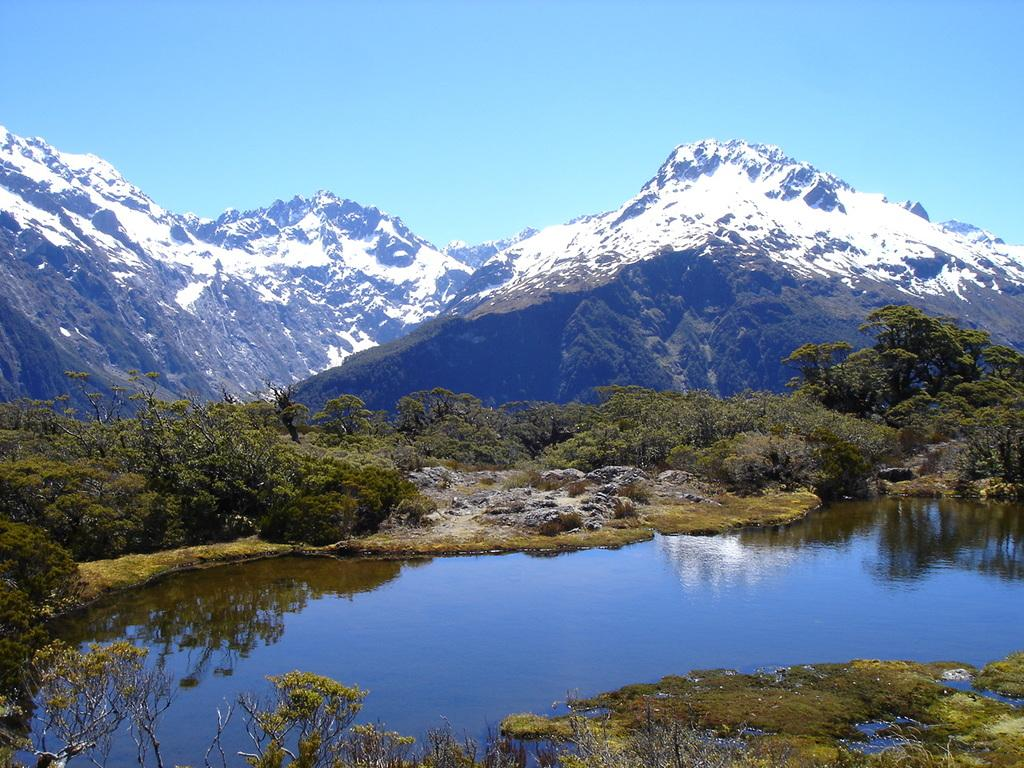What type of natural environment is depicted in the image? The image features many trees, plants, rocks, water, and mountains, suggesting a natural landscape. Can you describe the water in the image? The water is visible in the image, but its specific characteristics are not mentioned in the facts. What is visible in the background of the image? The sky, mountains, and snow are visible in the background of the image. Can you tell me how many honeycombs are hanging from the trees in the image? There is no mention of honeycombs in the image; it features trees, plants, rocks, water, and mountains. 